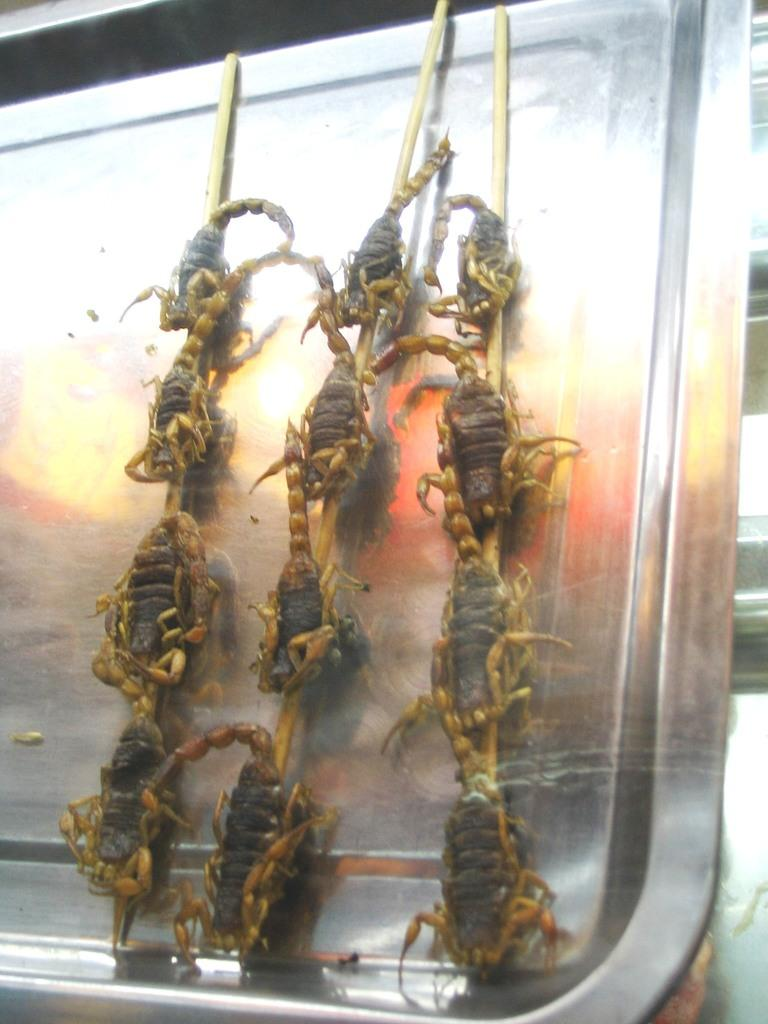What type of objects can be seen in the image? There are sticks and a metal object with animals on it in the image. Can you describe the metal object in the image? The metal object has animals on it, but no specific details about the animals or the object itself are provided. What can be seen in the background of the image? There are objects visible in the background of the image, but no specific details about these objects are provided. What type of treatment is being administered to the animals on the metal object in the image? There is no indication in the image that any treatment is being administered to the animals on the metal object. 